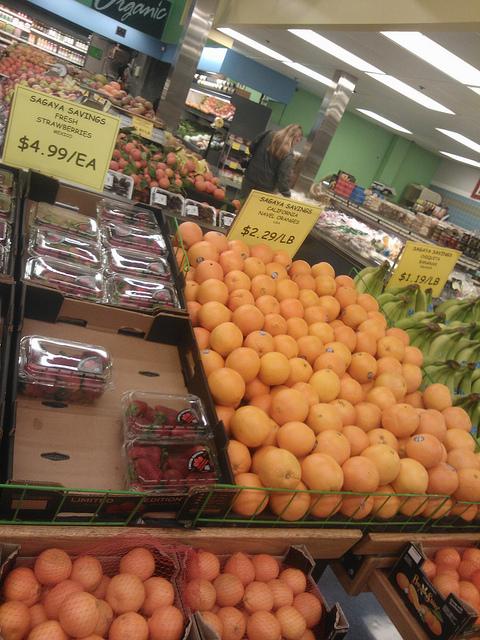Is this display in a grocery?
Short answer required. Yes. Can you purchase only one?
Write a very short answer. Yes. Is this a farmer's market?
Write a very short answer. No. What are the fruits being displayed in?
Be succinct. Oranges. What fruit is shown for $4.99?
Give a very brief answer. Strawberries. 